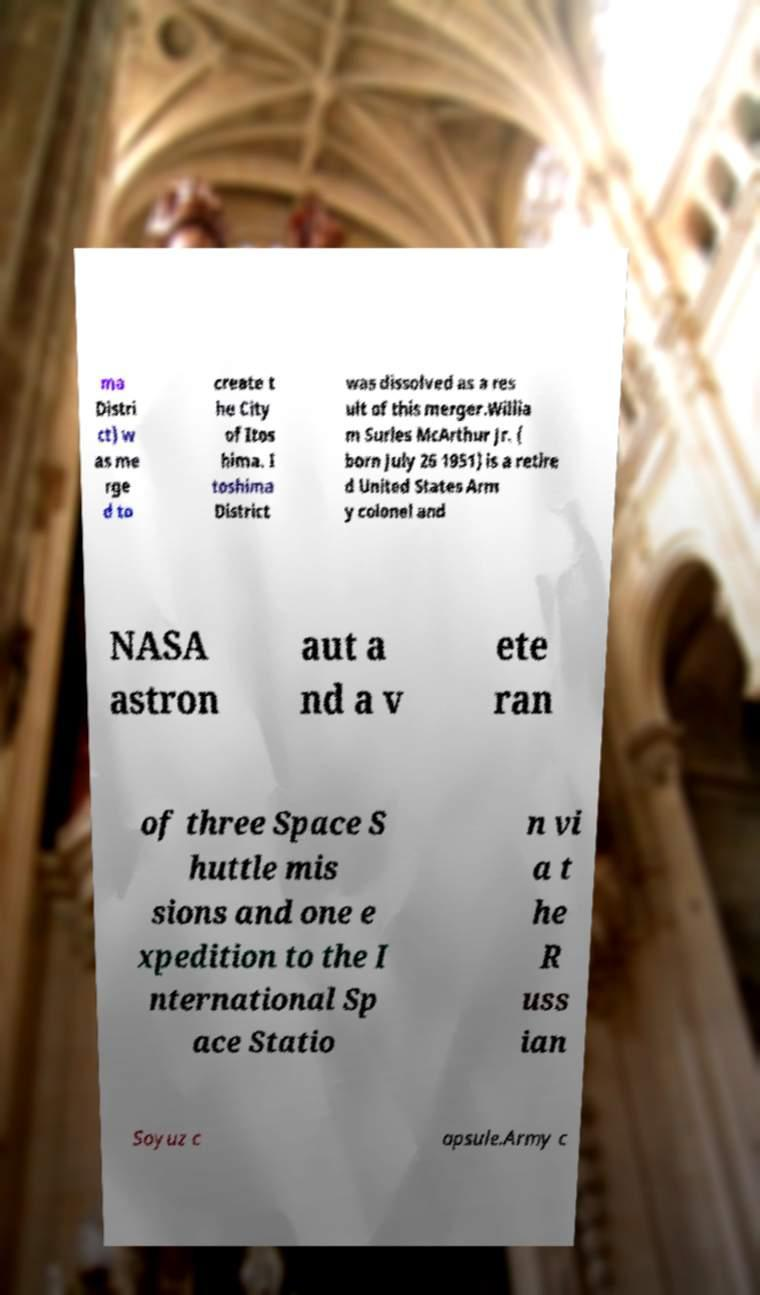Can you read and provide the text displayed in the image?This photo seems to have some interesting text. Can you extract and type it out for me? ma Distri ct) w as me rge d to create t he City of Itos hima. I toshima District was dissolved as a res ult of this merger.Willia m Surles McArthur Jr. ( born July 26 1951) is a retire d United States Arm y colonel and NASA astron aut a nd a v ete ran of three Space S huttle mis sions and one e xpedition to the I nternational Sp ace Statio n vi a t he R uss ian Soyuz c apsule.Army c 